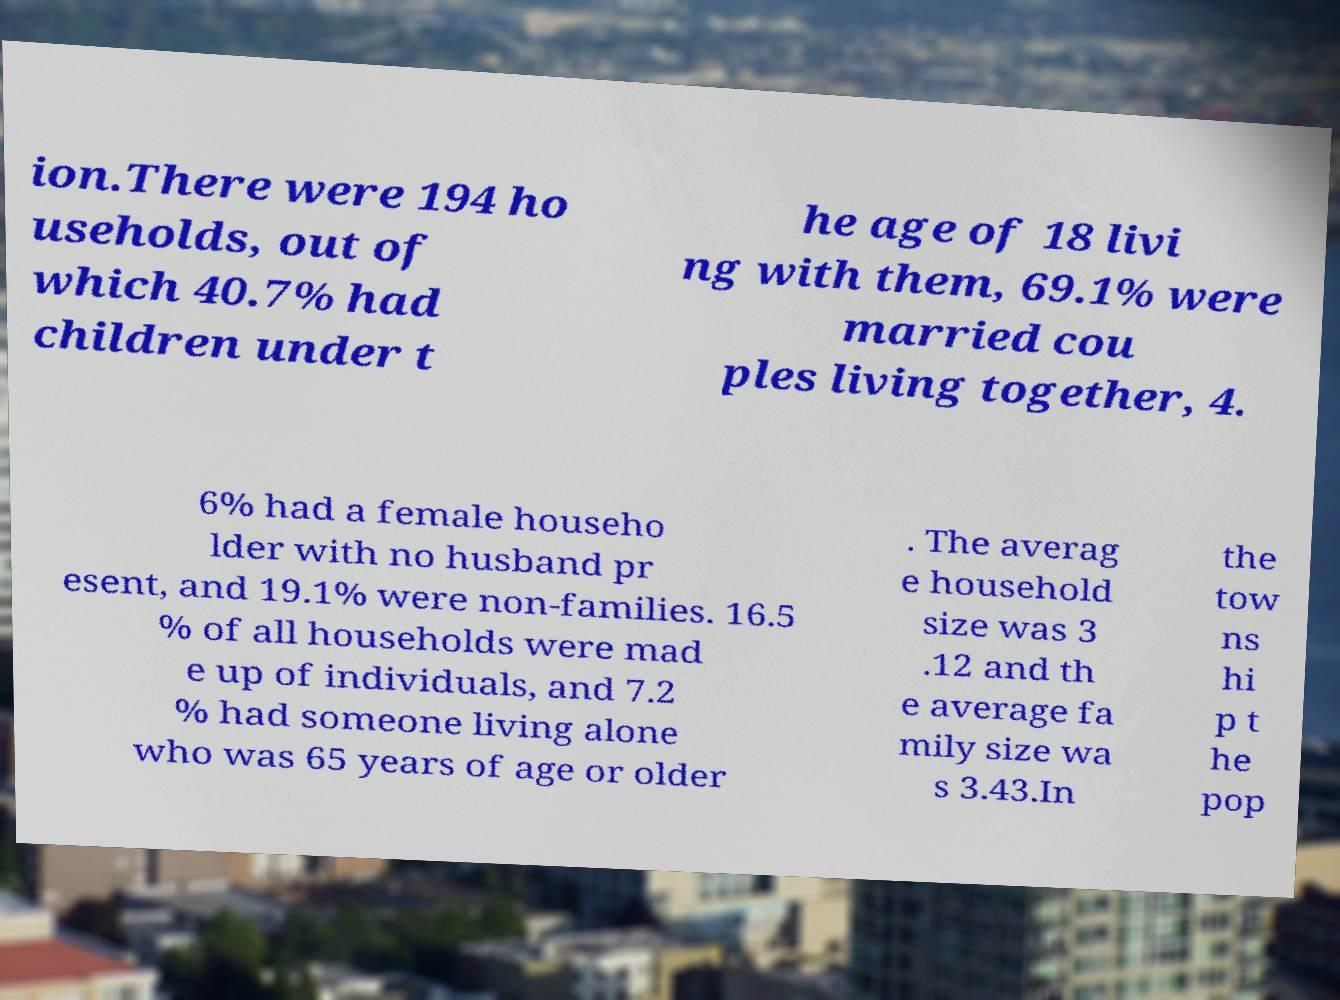Could you assist in decoding the text presented in this image and type it out clearly? ion.There were 194 ho useholds, out of which 40.7% had children under t he age of 18 livi ng with them, 69.1% were married cou ples living together, 4. 6% had a female househo lder with no husband pr esent, and 19.1% were non-families. 16.5 % of all households were mad e up of individuals, and 7.2 % had someone living alone who was 65 years of age or older . The averag e household size was 3 .12 and th e average fa mily size wa s 3.43.In the tow ns hi p t he pop 